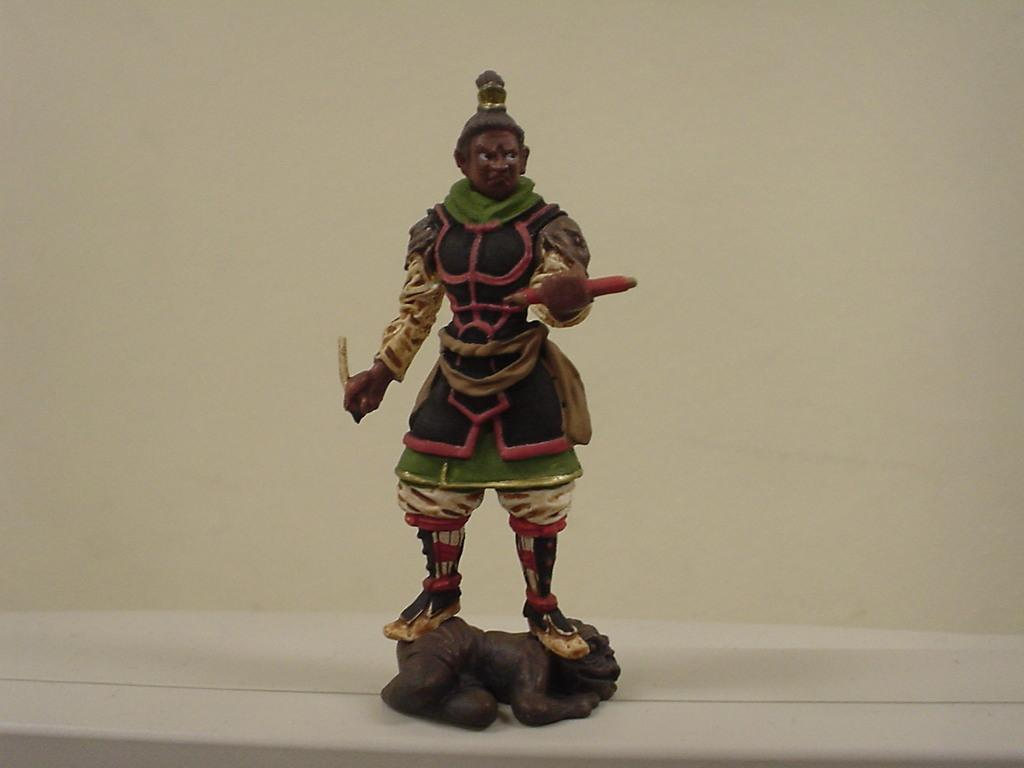What is the main subject in the image? There is a statue in the image. What can be seen in the background of the image? There is a wall in the background of the image. What type of doll can be seen using the statue in the image? There is no doll present in the image, and the statue is not being used by any object or person. 